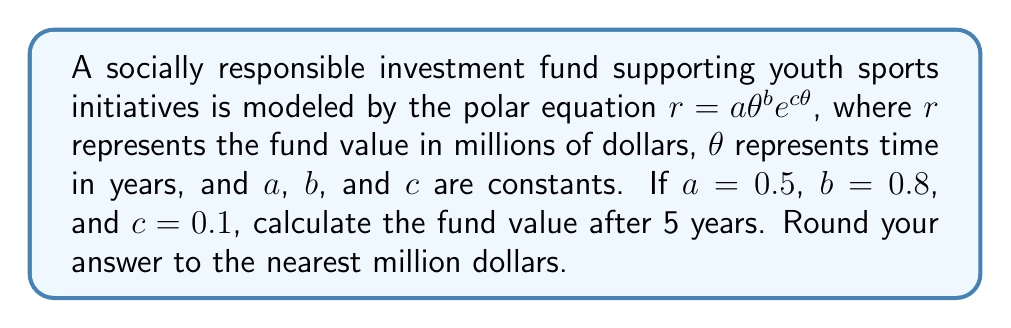Can you solve this math problem? To solve this problem, we need to follow these steps:

1) The given polar equation is:
   $r = a\theta^b e^{c\theta}$

2) We are given the values:
   $a = 0.5$
   $b = 0.8$
   $c = 0.1$
   $\theta = 5$ (as we want to know the value after 5 years)

3) Let's substitute these values into the equation:
   $r = 0.5 \cdot 5^{0.8} \cdot e^{0.1 \cdot 5}$

4) Let's calculate this step by step:
   
   a) First, calculate $5^{0.8}$:
      $5^{0.8} \approx 3.6239$
   
   b) Then, calculate $e^{0.1 \cdot 5} = e^{0.5}$:
      $e^{0.5} \approx 1.6487$
   
   c) Now, multiply all parts:
      $r = 0.5 \cdot 3.6239 \cdot 1.6487$
      $r \approx 2.9868$

5) This result is in millions of dollars. Rounding to the nearest million:
   $r \approx 3$ million dollars

Therefore, after 5 years, the fund value will be approximately 3 million dollars.
Answer: $3$ million dollars 